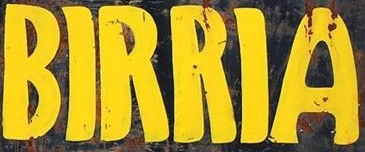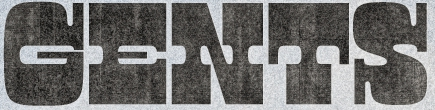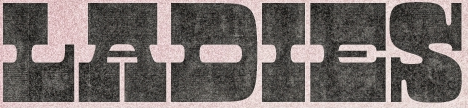What text is displayed in these images sequentially, separated by a semicolon? BIRRIA; GENTS; LADIES 